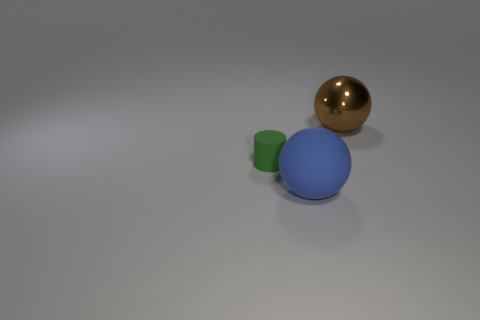What number of things are either green matte things or rubber things to the left of the big blue matte object?
Provide a succinct answer. 1. Do the green rubber cylinder and the matte ball have the same size?
Offer a terse response. No. There is a blue matte thing; are there any blue objects behind it?
Ensure brevity in your answer.  No. There is a object that is in front of the brown shiny ball and right of the small green rubber cylinder; what size is it?
Provide a succinct answer. Large. What number of things are large brown metal spheres or large cyan rubber cylinders?
Keep it short and to the point. 1. There is a metal thing; is its size the same as the blue sphere that is to the right of the matte cylinder?
Make the answer very short. Yes. There is a ball left of the large sphere that is behind the sphere that is in front of the tiny rubber thing; what size is it?
Offer a terse response. Large. Is there a small green cylinder?
Provide a short and direct response. Yes. What number of other big metal balls have the same color as the large metallic sphere?
Provide a short and direct response. 0. What number of things are either spheres behind the tiny green matte cylinder or objects that are in front of the green rubber object?
Your answer should be compact. 2. 